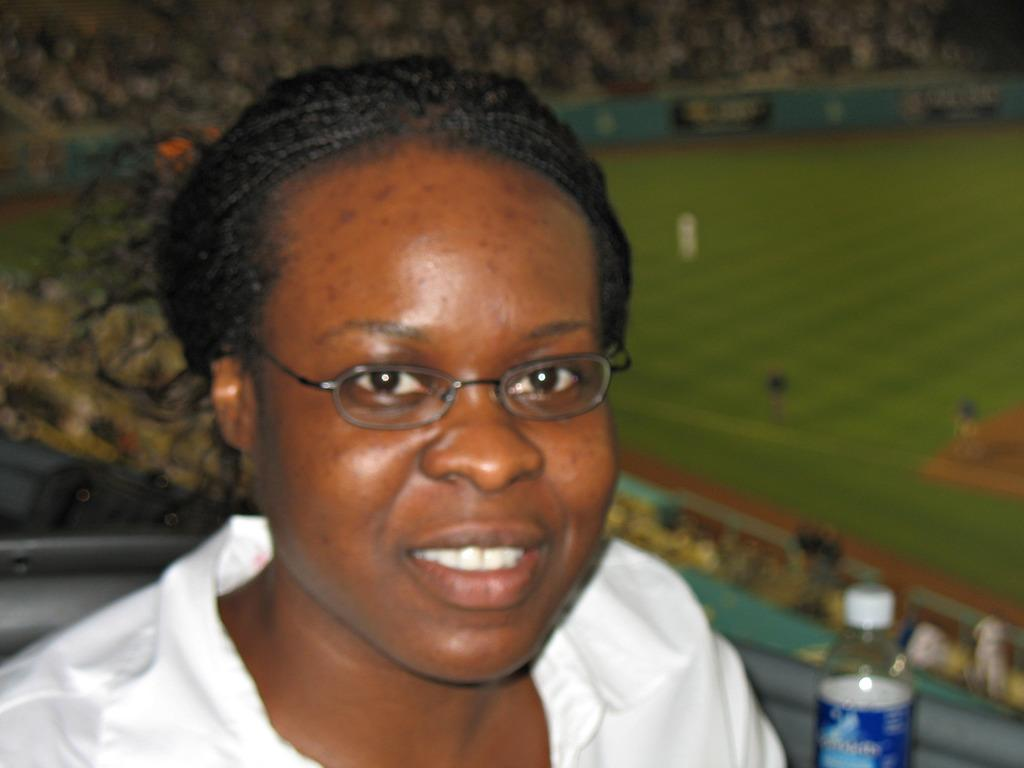Who is present in the image? There is a woman in the image. What object can be seen in the image? There is a bottle in the image. Can you describe the background of the image? The background of the image is blurry. What type of sign can be seen at the seashore in the image? There is no seashore or sign present in the image. 